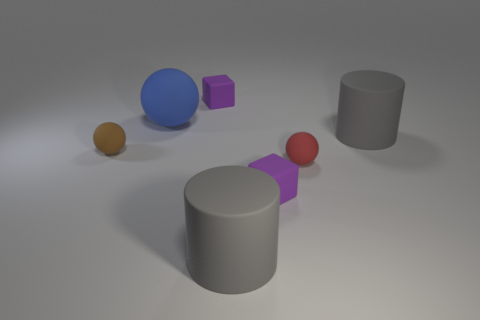The sphere that is both on the right side of the brown thing and behind the red sphere is made of what material?
Your answer should be very brief. Rubber. Are there any other large matte objects of the same shape as the brown matte thing?
Give a very brief answer. Yes. Are there any matte spheres that are behind the cube that is behind the large blue rubber thing?
Offer a terse response. No. What number of small yellow cylinders are made of the same material as the red thing?
Your response must be concise. 0. Are there any blue matte objects?
Offer a terse response. Yes. Is the material of the red object the same as the small object in front of the red matte sphere?
Provide a succinct answer. Yes. Are there more small brown spheres in front of the red object than spheres?
Provide a short and direct response. No. Is there any other thing that has the same size as the red rubber thing?
Keep it short and to the point. Yes. Is the color of the big ball the same as the cylinder in front of the tiny red thing?
Your response must be concise. No. Are there the same number of purple rubber objects right of the tiny red matte object and spheres on the right side of the large blue sphere?
Offer a very short reply. No. 